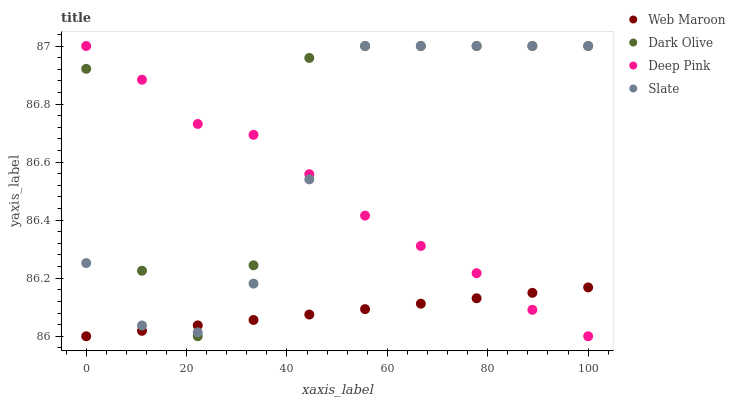Does Web Maroon have the minimum area under the curve?
Answer yes or no. Yes. Does Dark Olive have the maximum area under the curve?
Answer yes or no. Yes. Does Dark Olive have the minimum area under the curve?
Answer yes or no. No. Does Web Maroon have the maximum area under the curve?
Answer yes or no. No. Is Web Maroon the smoothest?
Answer yes or no. Yes. Is Dark Olive the roughest?
Answer yes or no. Yes. Is Dark Olive the smoothest?
Answer yes or no. No. Is Web Maroon the roughest?
Answer yes or no. No. Does Web Maroon have the lowest value?
Answer yes or no. Yes. Does Dark Olive have the lowest value?
Answer yes or no. No. Does Deep Pink have the highest value?
Answer yes or no. Yes. Does Web Maroon have the highest value?
Answer yes or no. No. Does Deep Pink intersect Web Maroon?
Answer yes or no. Yes. Is Deep Pink less than Web Maroon?
Answer yes or no. No. Is Deep Pink greater than Web Maroon?
Answer yes or no. No. 